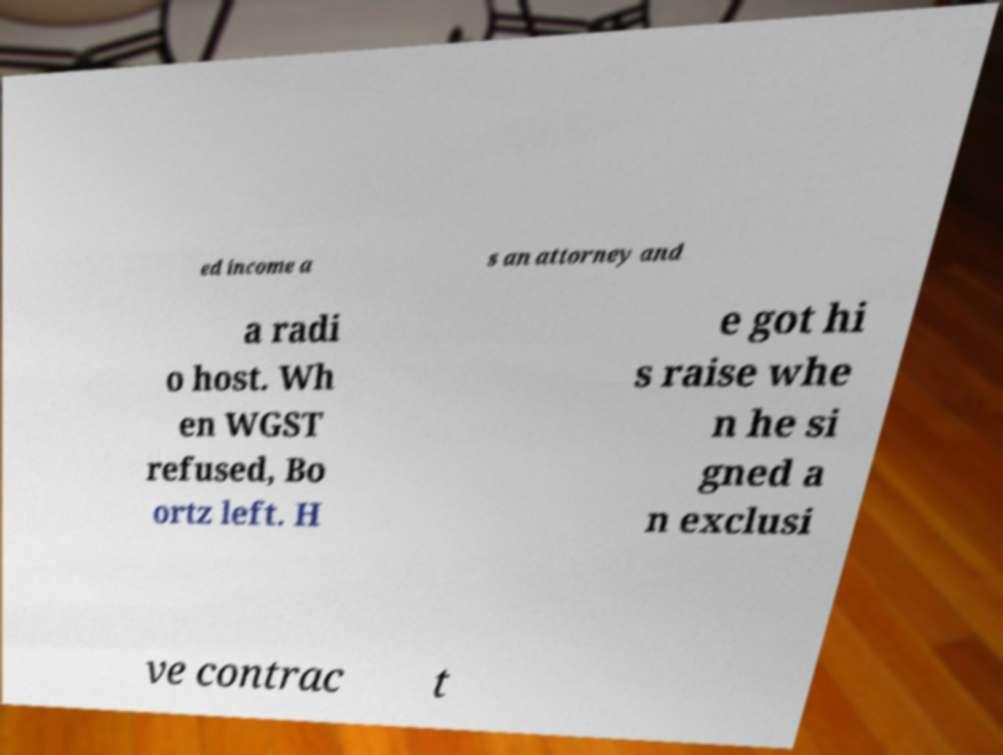Can you accurately transcribe the text from the provided image for me? ed income a s an attorney and a radi o host. Wh en WGST refused, Bo ortz left. H e got hi s raise whe n he si gned a n exclusi ve contrac t 